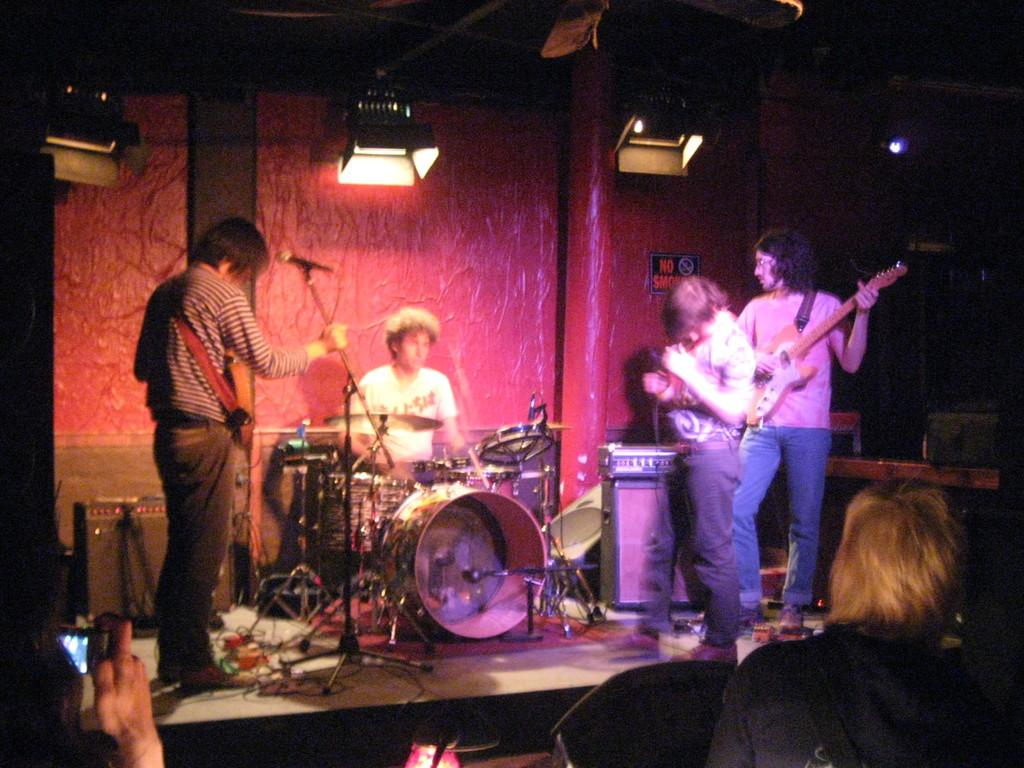How many people are in the image? There are four persons in the image. What are the persons doing in the image? The persons are playing musical instruments. What can be seen in the background of the image? There is a wall in the background of the image. What is the source of light visible at the top of the image? The light visible at the top of the image could be a ceiling light or a spotlight. Can you see a bear playing a musical instrument in the image? No, there is no bear present in the image. The persons playing musical instruments are human. 